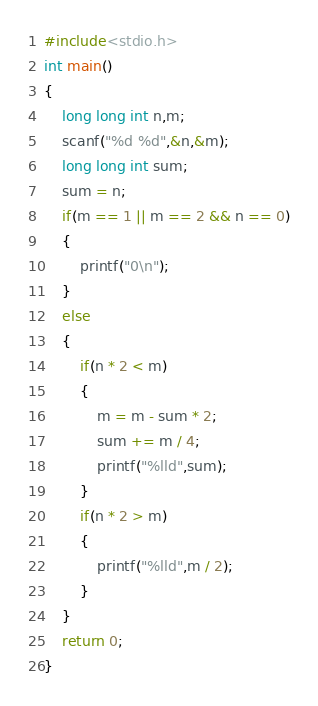Convert code to text. <code><loc_0><loc_0><loc_500><loc_500><_C_>#include<stdio.h>
int main()
{
	long long int n,m;
	scanf("%d %d",&n,&m);
	long long int sum;
	sum = n;
	if(m == 1 || m == 2 && n == 0)
	{
		printf("0\n");
	}
	else
	{
		if(n * 2 < m)
		{
			m = m - sum * 2;
			sum += m / 4;
			printf("%lld",sum);
		}
		if(n * 2 > m)
		{
			printf("%lld",m / 2);
		}
	}
	return 0;
}</code> 